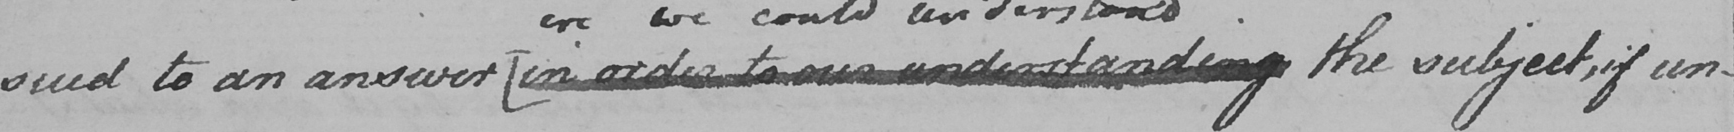Please transcribe the handwritten text in this image. sued to an answer  [ in order to our understanding the subject , if un- 